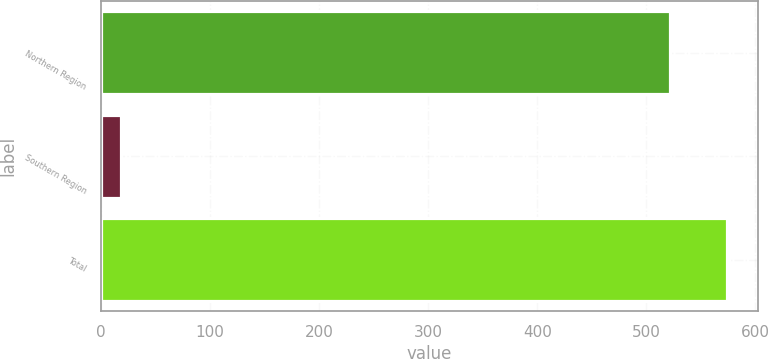Convert chart to OTSL. <chart><loc_0><loc_0><loc_500><loc_500><bar_chart><fcel>Northern Region<fcel>Southern Region<fcel>Total<nl><fcel>521.4<fcel>18.6<fcel>573.86<nl></chart> 